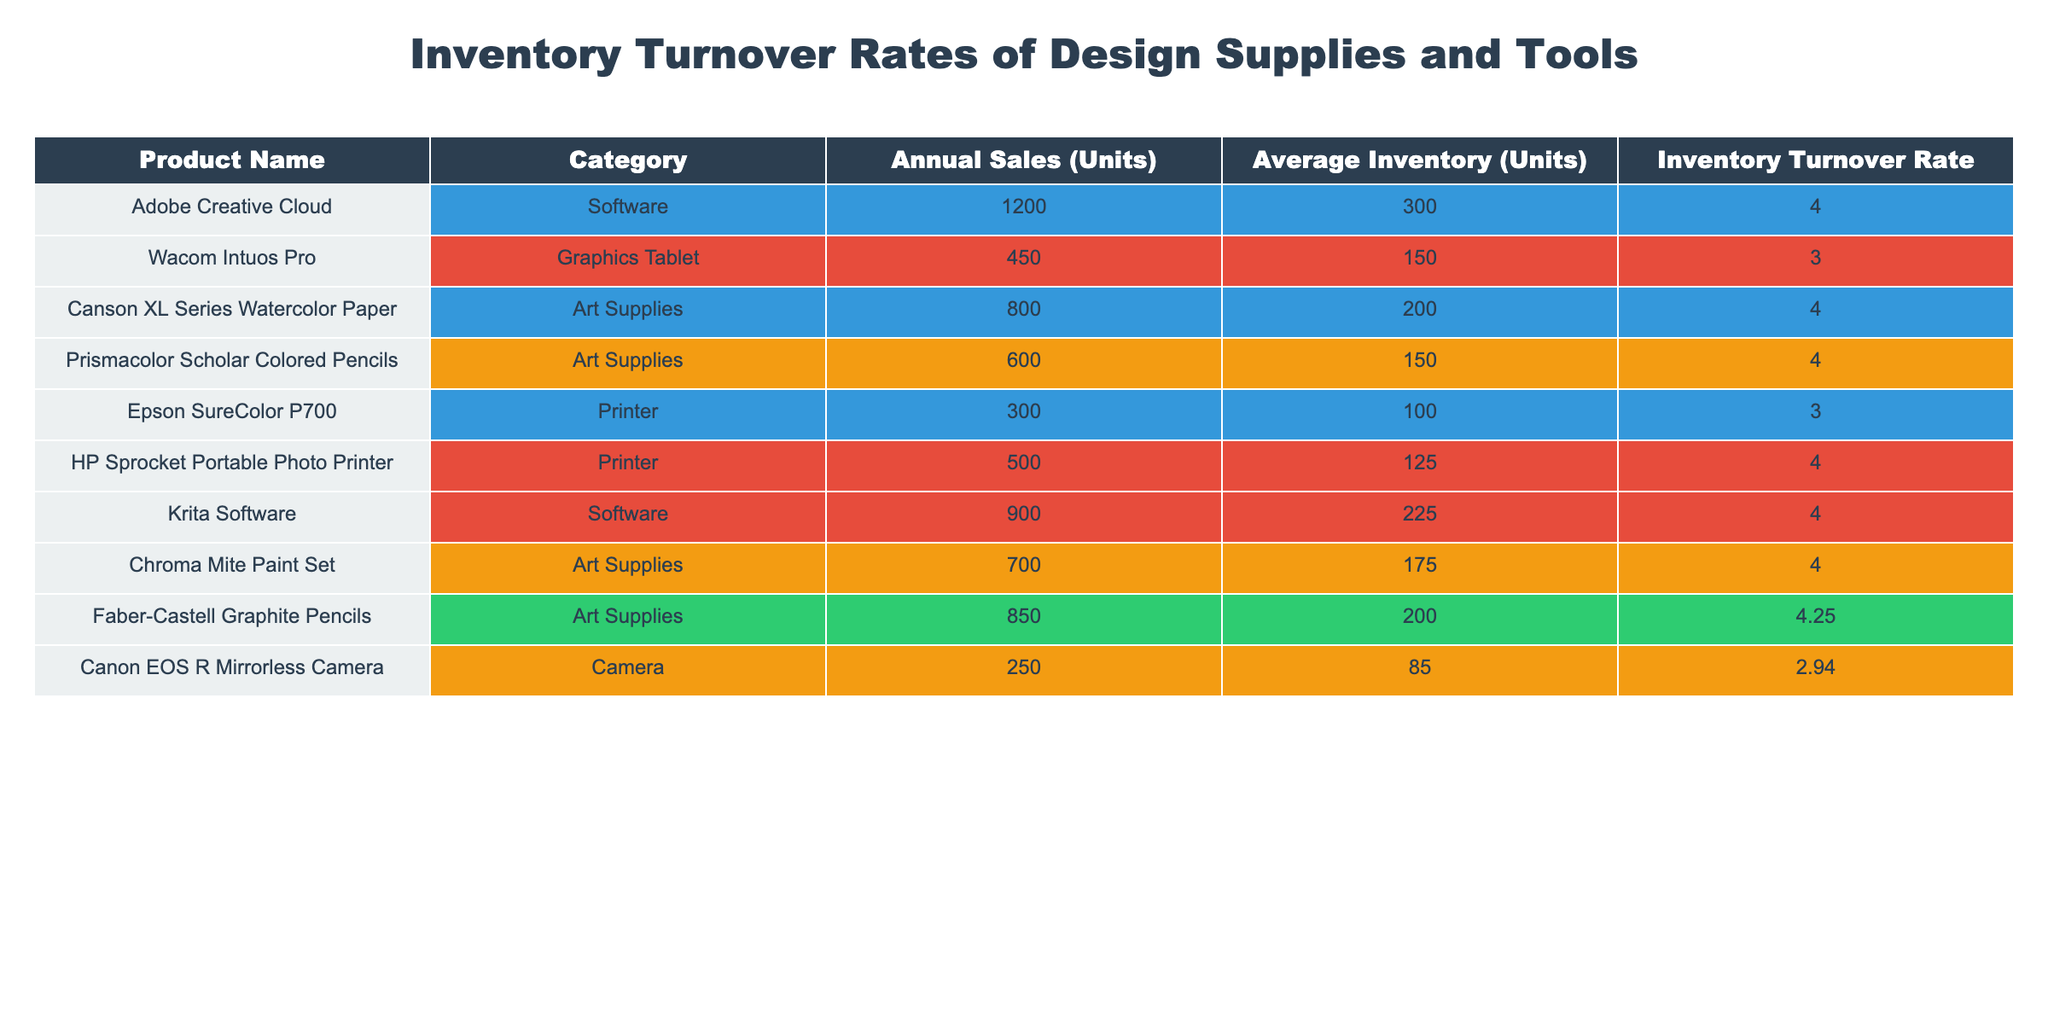What is the Inventory Turnover Rate of Faber-Castell Graphite Pencils? The table lists the Inventory Turnover Rate for each product, and for Faber-Castell Graphite Pencils, it shows 4.25.
Answer: 4.25 Which product category has the highest Inventory Turnover Rate? By comparing the Inventory Turnover Rates across all categories, the highest is 4.25 for Faber-Castell Graphite Pencils under Art Supplies.
Answer: Art Supplies How many units of Adobe Creative Cloud are sold annually? Referring to the table, Adobe Creative Cloud's Annual Sales (Units) is clearly stated as 1200.
Answer: 1200 Is the Inventory Turnover Rate for Canon EOS R Mirrorless Camera greater than 3? The Inventory Turnover Rate for Canon EOS R Mirrorless Camera is 2.94 according to the table, which is less than 3.
Answer: No What is the average Inventory Turnover Rate for all products listed? First, sum all the Inventory Turnover Rates: 4.0 + 3.0 + 4.0 + 4.0 + 3.0 + 4.0 + 4.0 + 4.25 + 2.94, which equals 33.49. Then, divide by the number of products (9): 33.49 / 9 = approximately 3.72.
Answer: 3.72 Which product has the lowest Inventory Turnover Rate? Looking at the table, Canon EOS R Mirrorless Camera has the Inventory Turnover Rate of 2.94, which is the lowest among all listed products.
Answer: Canon EOS R Mirrorless Camera If Wacom Intuos Pro had 100 more units in average inventory, what would its Inventory Turnover Rate become? The current average inventory for Wacom Intuos Pro is 150. Adding 100 gives 250. Using the formula: Inventory Turnover Rate = Annual Sales (Units) / Average Inventory (Units), the new rate would be 450 / 250 = 1.8.
Answer: 1.8 Which two products have the same Inventory Turnover Rate of 4.0? The products with an Inventory Turnover Rate of 4.0 are Adobe Creative Cloud and Canson XL Series Watercolor Paper, as seen in the table.
Answer: Adobe Creative Cloud and Canson XL Series Watercolor Paper What is the total Annual Sales (Units) for all the products in the Art Supplies category? The Annual Sales (Units) figures for Art Supplies listed are 800 (Canson XL Series Watercolor Paper), 600 (Prismacolor Scholar Colored Pencils), 700 (Chroma Mite Paint Set), and 850 (Faber-Castell Graphite Pencils). Summing these gives: 800 + 600 + 700 + 850 = 2950.
Answer: 2950 